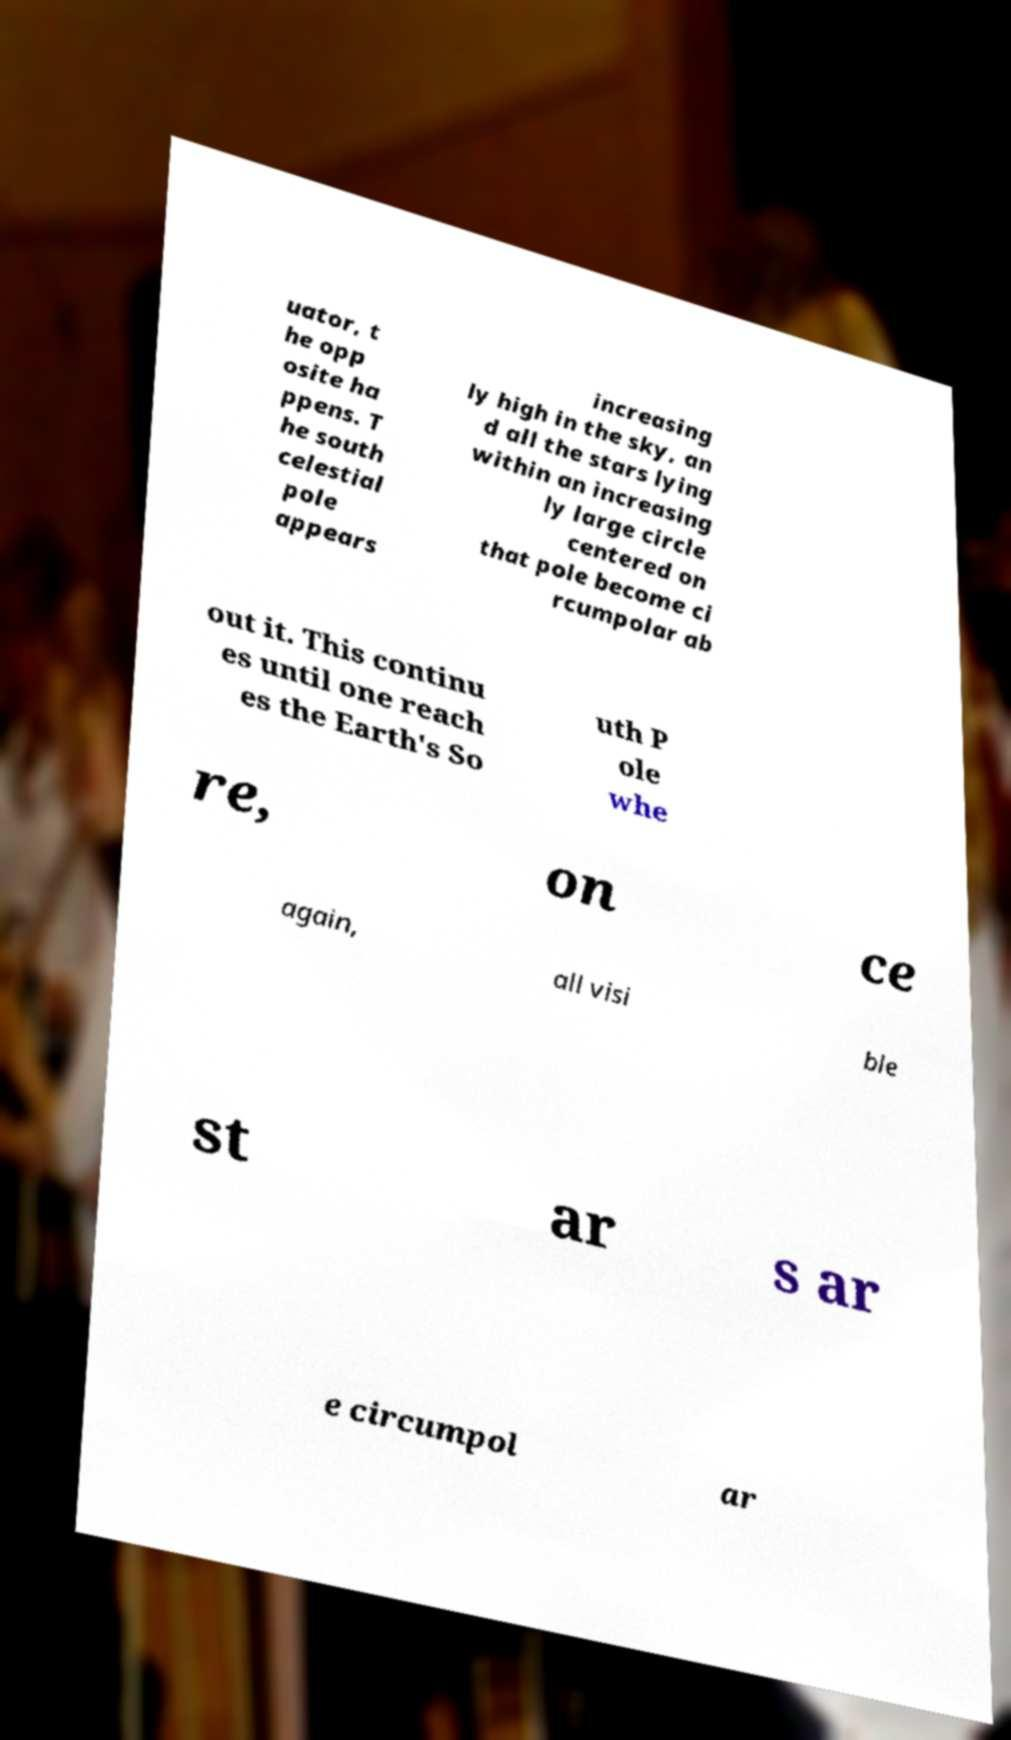I need the written content from this picture converted into text. Can you do that? uator, t he opp osite ha ppens. T he south celestial pole appears increasing ly high in the sky, an d all the stars lying within an increasing ly large circle centered on that pole become ci rcumpolar ab out it. This continu es until one reach es the Earth's So uth P ole whe re, on ce again, all visi ble st ar s ar e circumpol ar 